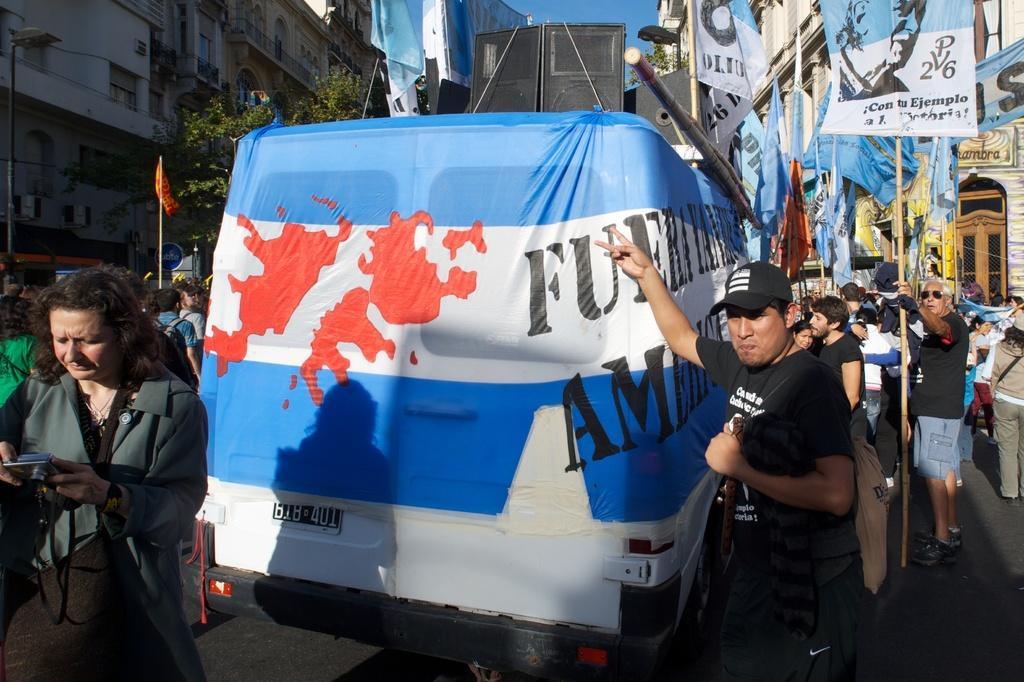Could you give a brief overview of what you see in this image? In the center of the image there is a vehicle on the road. On the vehicle we can see speakers and flags. On the right side of the image we can see persons, flags and buildings. On the left side of the image we can see light poles, flags, persons, trees and buildings. In the background there is a sky. 